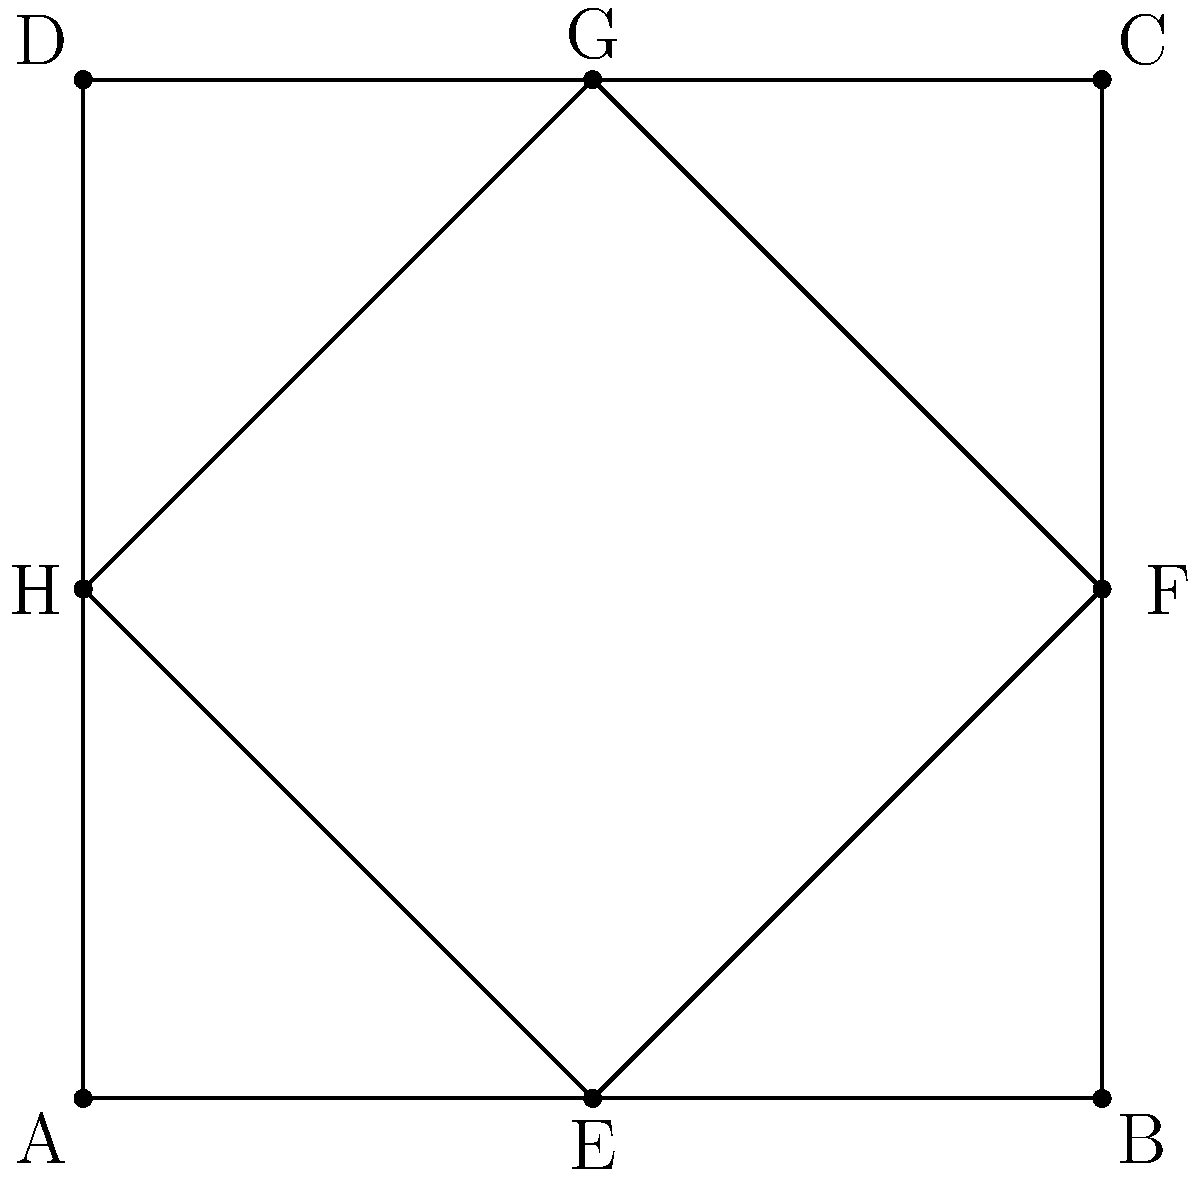In this traditional quilt pattern, quadrilateral ABCD represents the entire quilt, while quadrilateral EFGH represents an inner design element. If ABCD is a square with side length 4 units, and EFGH is formed by connecting the midpoints of the sides of ABCD, prove that EFGH is congruent to a square with side length $2\sqrt{2}$ units. Let's approach this step-by-step:

1) First, we need to recognize that EFGH is a square. This is because:
   - Its vertices are the midpoints of the sides of a square (ABCD).
   - Connecting midpoints of a quadrilateral always forms a parallelogram.
   - In a square, the diagonals are equal and perpendicular, bisecting each other.

2) Now, let's focus on triangle AEH:
   - AE = 2 units (half of AB)
   - AH = 2 units (half of AD)
   - Angle EAH = 90° (as ABCD is a square)

3) Therefore, triangle AEH is an isosceles right triangle.

4) In an isosceles right triangle, the hypotenuse can be calculated using the Pythagorean theorem:
   $EH^2 = AE^2 + AH^2 = 2^2 + 2^2 = 8$

5) So, $EH = \sqrt{8} = 2\sqrt{2}$ units

6) As EFGH is a square, all its sides are equal to $2\sqrt{2}$ units.

7) Therefore, EFGH is congruent to a square with side length $2\sqrt{2}$ units.

This proof aligns with traditional geometric principles and showcases the elegant symmetry often found in quilt patterns, reinforcing the beauty of mathematical concepts in everyday designs.
Answer: EFGH is a square with side length $2\sqrt{2}$ units 